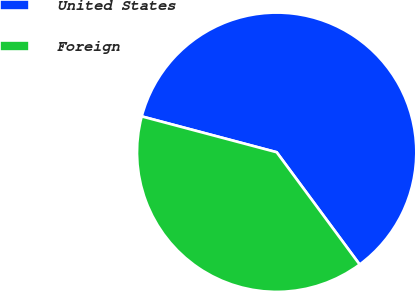Convert chart to OTSL. <chart><loc_0><loc_0><loc_500><loc_500><pie_chart><fcel>United States<fcel>Foreign<nl><fcel>60.74%<fcel>39.26%<nl></chart> 